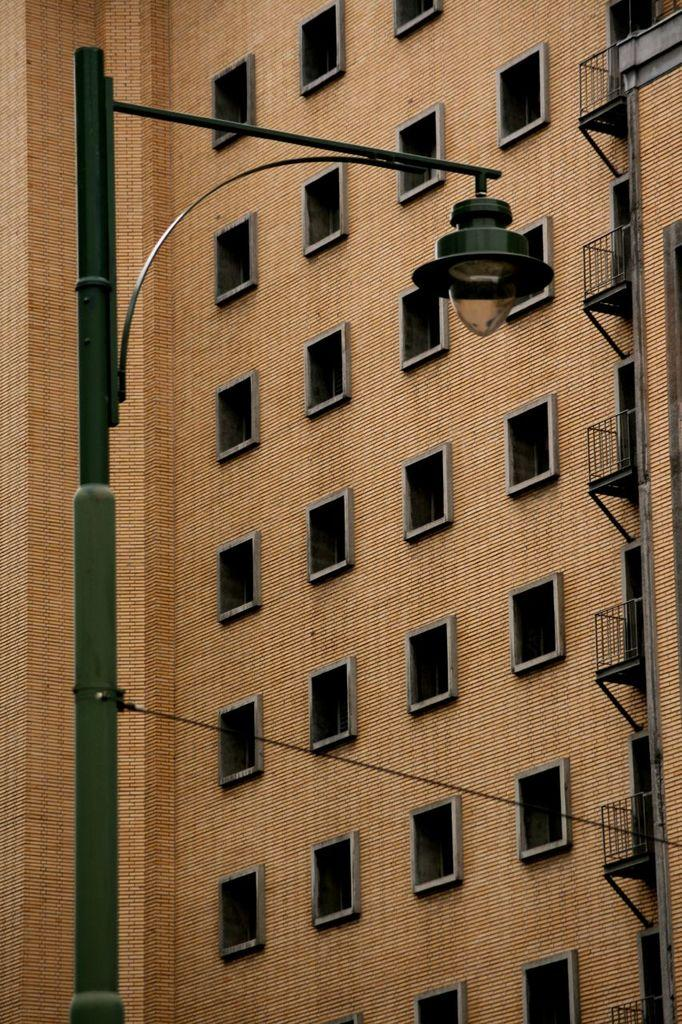What structure is present in the image? There is a light pole in the image. What type of man-made structure can be seen in the image? There is a building in the image. What features can be observed on the building? The building has windows and a balcony. What type of insurance policy is being discussed on the balcony of the building in the image? There is no discussion or mention of insurance in the image; it only shows a building with windows and a balcony. 